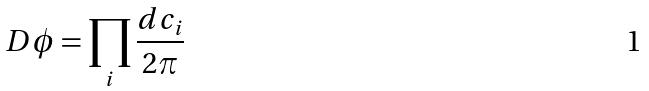<formula> <loc_0><loc_0><loc_500><loc_500>D \phi = \prod _ { i } \frac { d c _ { i } } { 2 \pi }</formula> 